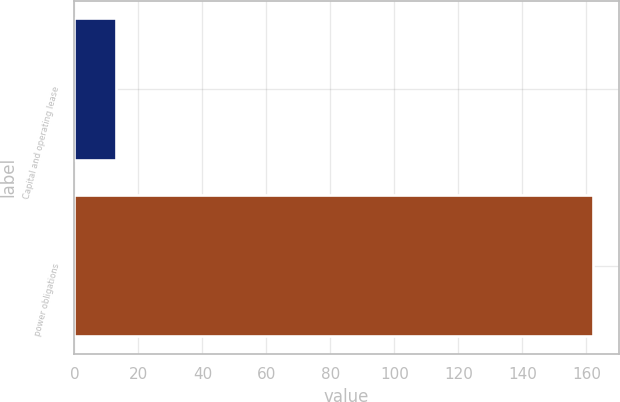<chart> <loc_0><loc_0><loc_500><loc_500><bar_chart><fcel>Capital and operating lease<fcel>power obligations<nl><fcel>13<fcel>162<nl></chart> 